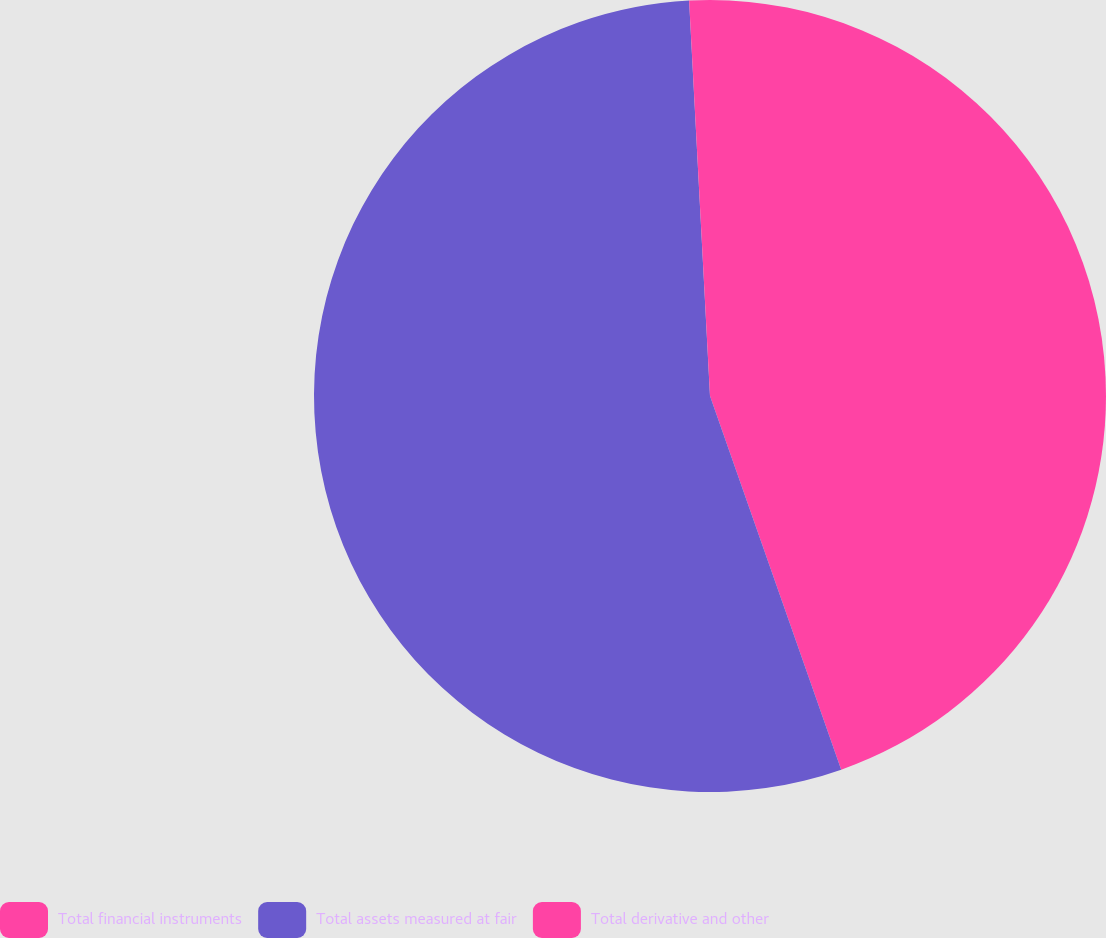Convert chart. <chart><loc_0><loc_0><loc_500><loc_500><pie_chart><fcel>Total financial instruments<fcel>Total assets measured at fair<fcel>Total derivative and other<nl><fcel>44.63%<fcel>54.54%<fcel>0.84%<nl></chart> 